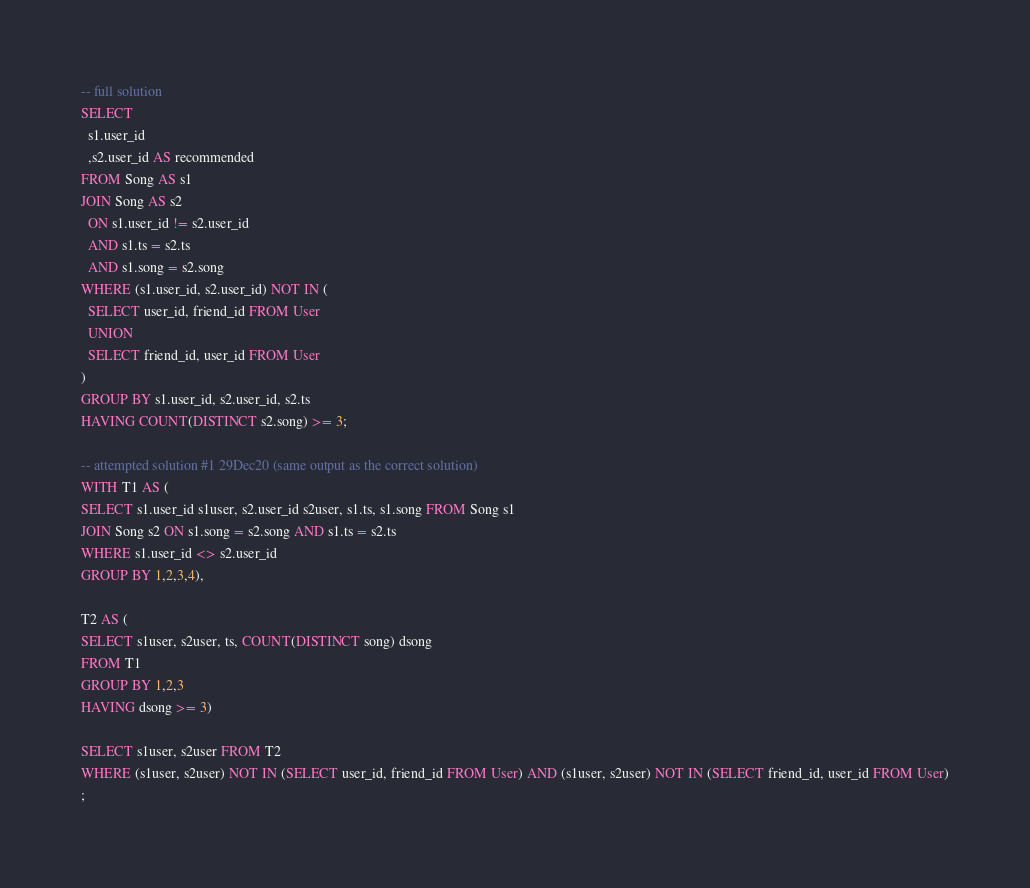Convert code to text. <code><loc_0><loc_0><loc_500><loc_500><_SQL_>-- full solution
SELECT
  s1.user_id
  ,s2.user_id AS recommended
FROM Song AS s1
JOIN Song AS s2
  ON s1.user_id != s2.user_id
  AND s1.ts = s2.ts
  AND s1.song = s2.song
WHERE (s1.user_id, s2.user_id) NOT IN (
  SELECT user_id, friend_id FROM User
  UNION
  SELECT friend_id, user_id FROM User
)
GROUP BY s1.user_id, s2.user_id, s2.ts
HAVING COUNT(DISTINCT s2.song) >= 3;

-- attempted solution #1 29Dec20 (same output as the correct solution)
WITH T1 AS (
SELECT s1.user_id s1user, s2.user_id s2user, s1.ts, s1.song FROM Song s1
JOIN Song s2 ON s1.song = s2.song AND s1.ts = s2.ts
WHERE s1.user_id <> s2.user_id
GROUP BY 1,2,3,4),

T2 AS (
SELECT s1user, s2user, ts, COUNT(DISTINCT song) dsong
FROM T1
GROUP BY 1,2,3
HAVING dsong >= 3)

SELECT s1user, s2user FROM T2
WHERE (s1user, s2user) NOT IN (SELECT user_id, friend_id FROM User) AND (s1user, s2user) NOT IN (SELECT friend_id, user_id FROM User)
;</code> 